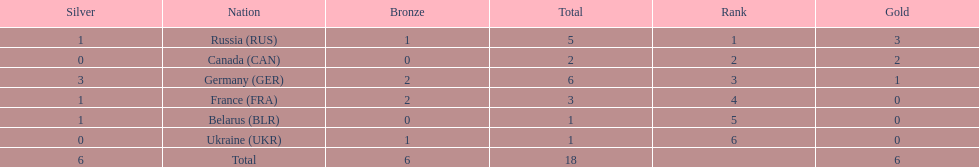Write the full table. {'header': ['Silver', 'Nation', 'Bronze', 'Total', 'Rank', 'Gold'], 'rows': [['1', 'Russia\xa0(RUS)', '1', '5', '1', '3'], ['0', 'Canada\xa0(CAN)', '0', '2', '2', '2'], ['3', 'Germany\xa0(GER)', '2', '6', '3', '1'], ['1', 'France\xa0(FRA)', '2', '3', '4', '0'], ['1', 'Belarus\xa0(BLR)', '0', '1', '5', '0'], ['0', 'Ukraine\xa0(UKR)', '1', '1', '6', '0'], ['6', 'Total', '6', '18', '', '6']]} Which country won the same amount of silver medals as the french and the russians? Belarus. 